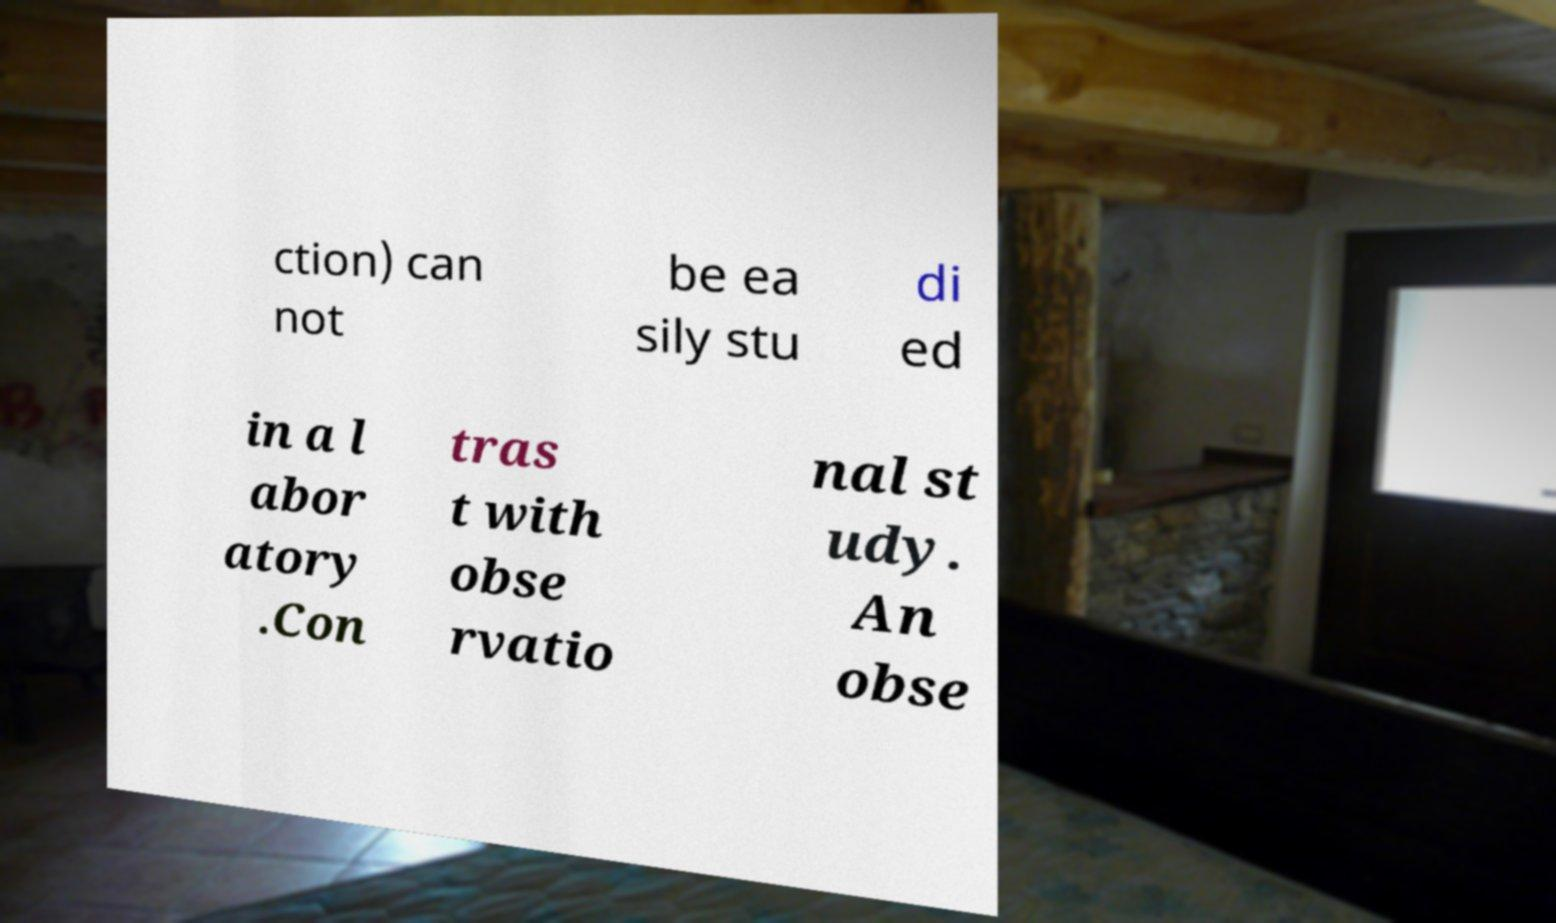Please read and relay the text visible in this image. What does it say? ction) can not be ea sily stu di ed in a l abor atory .Con tras t with obse rvatio nal st udy. An obse 